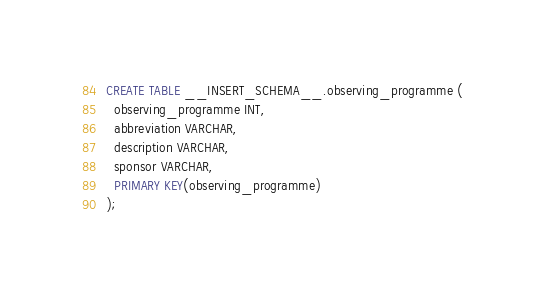<code> <loc_0><loc_0><loc_500><loc_500><_SQL_>CREATE TABLE __INSERT_SCHEMA__.observing_programme (
  observing_programme INT,
  abbreviation VARCHAR,
  description VARCHAR,
  sponsor VARCHAR,
  PRIMARY KEY(observing_programme)
);
</code> 